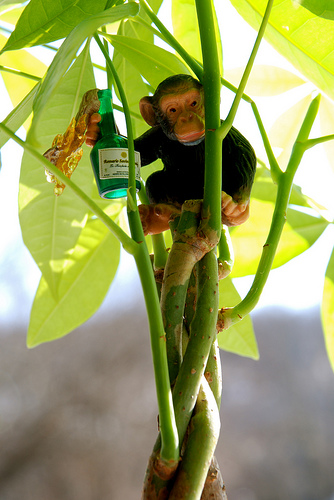<image>
Is the monkey in the houseplant? Yes. The monkey is contained within or inside the houseplant, showing a containment relationship. 